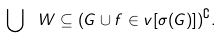<formula> <loc_0><loc_0><loc_500><loc_500>\bigcup \ W \subseteq ( G \cup f \in v [ \sigma ( G ) ] ) ^ { \complement } .</formula> 